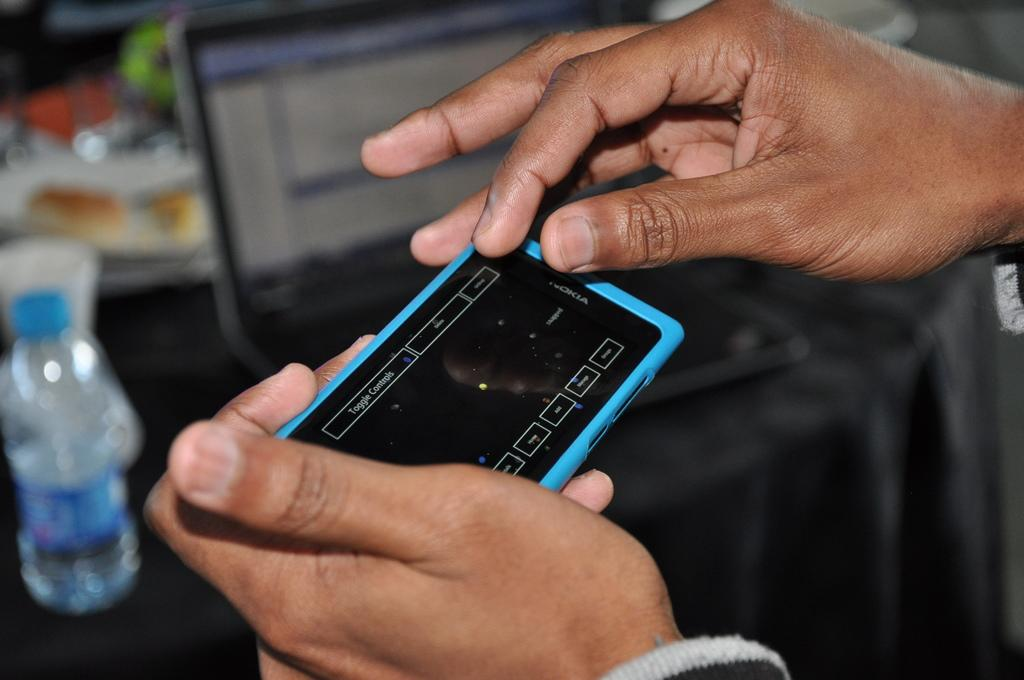What is the person in the image holding? The person is holding a phone. What objects can be seen on the table in the image? There is a bottle, a plate, a cup, and a laptop on the table. What is covering the table in the image? The table is covered with a black cloth. What type of shirt is the person wearing in the image? The provided facts do not mention the person's shirt, so we cannot determine the type of shirt they are wearing. --- 